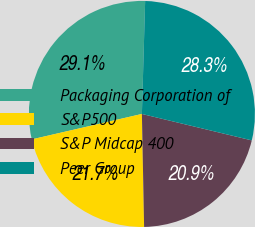Convert chart to OTSL. <chart><loc_0><loc_0><loc_500><loc_500><pie_chart><fcel>Packaging Corporation of<fcel>S&P500<fcel>S&P Midcap 400<fcel>Peer Group<nl><fcel>29.07%<fcel>21.7%<fcel>20.93%<fcel>28.3%<nl></chart> 